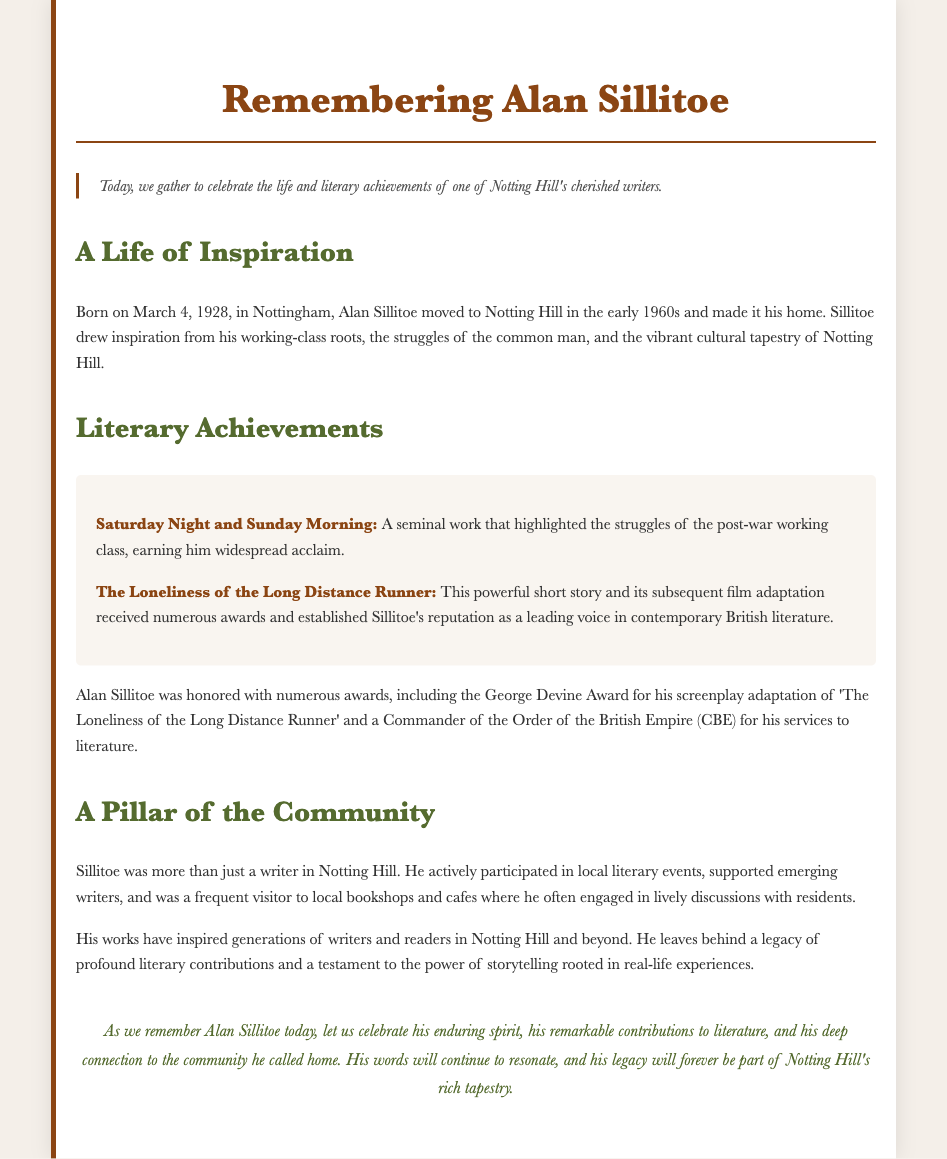What date was Alan Sillitoe born? The document states Alan Sillitoe was born on March 4, 1928.
Answer: March 4, 1928 What was one of Sillitoe's notable works? The document mentions "Saturday Night and Sunday Morning" as a seminal work.
Answer: Saturday Night and Sunday Morning Which award did Sillitoe receive for his screenplay adaptation? The document indicates he won the George Devine Award for his screenplay.
Answer: George Devine Award Where did Alan Sillitoe live after moving in the 1960s? The document specifies he moved to Notting Hill in the early 1960s.
Answer: Notting Hill What does Sillitoe's writing primarily focus on? According to the document, he drew inspiration from the struggles of the common man.
Answer: Common man struggles How did Sillitoe engage with the local community? The document highlights that he participated in local literary events and supported emerging writers.
Answer: Local literary events What recognition did Sillitoe receive for his services to literature? The document states he was made a Commander of the Order of the British Empire (CBE).
Answer: CBE What impact did Sillitoe have on future generations? The document notes his works inspired generations of writers and readers.
Answer: Inspired generations 